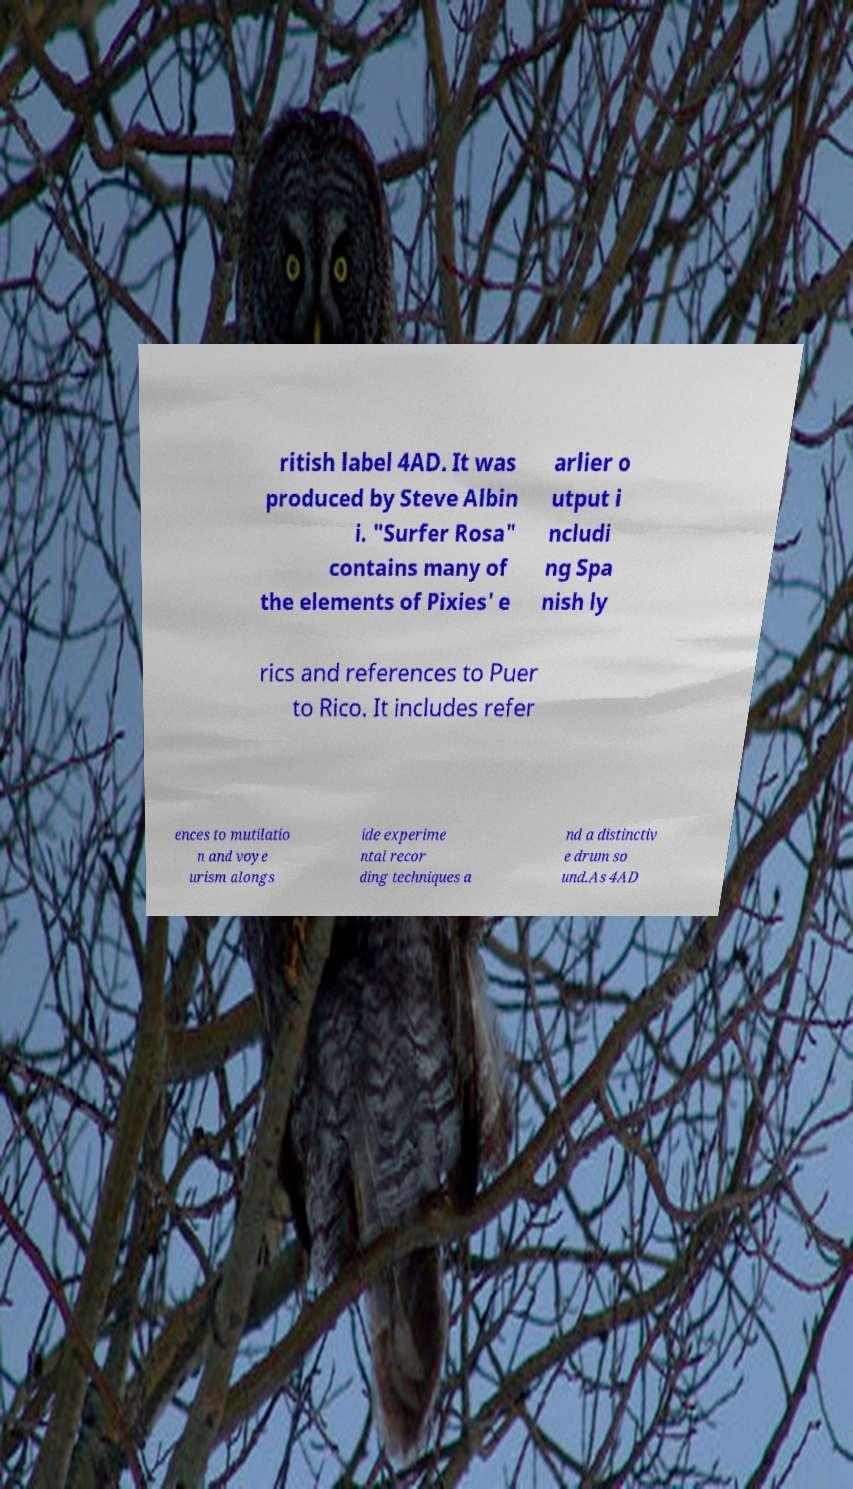Could you extract and type out the text from this image? ritish label 4AD. It was produced by Steve Albin i. "Surfer Rosa" contains many of the elements of Pixies' e arlier o utput i ncludi ng Spa nish ly rics and references to Puer to Rico. It includes refer ences to mutilatio n and voye urism alongs ide experime ntal recor ding techniques a nd a distinctiv e drum so und.As 4AD 